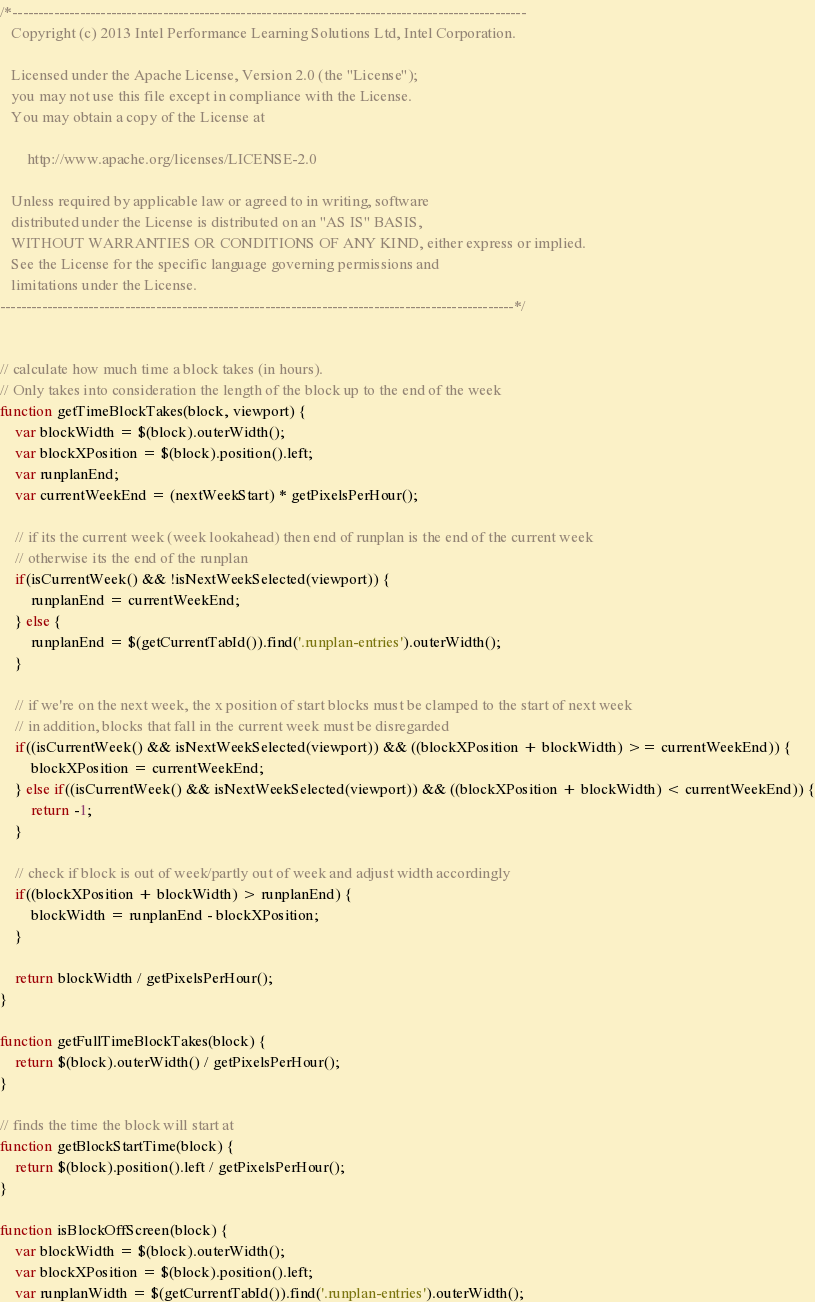<code> <loc_0><loc_0><loc_500><loc_500><_JavaScript_>/*---------------------------------------------------------------------------------------------------
   Copyright (c) 2013 Intel Performance Learning Solutions Ltd, Intel Corporation.

   Licensed under the Apache License, Version 2.0 (the "License");
   you may not use this file except in compliance with the License.
   You may obtain a copy of the License at

       http://www.apache.org/licenses/LICENSE-2.0

   Unless required by applicable law or agreed to in writing, software
   distributed under the License is distributed on an "AS IS" BASIS,
   WITHOUT WARRANTIES OR CONDITIONS OF ANY KIND, either express or implied.
   See the License for the specific language governing permissions and
   limitations under the License.
---------------------------------------------------------------------------------------------------*/


// calculate how much time a block takes (in hours). 
// Only takes into consideration the length of the block up to the end of the week
function getTimeBlockTakes(block, viewport) {
	var blockWidth = $(block).outerWidth();
	var blockXPosition = $(block).position().left;
	var runplanEnd;
	var currentWeekEnd = (nextWeekStart) * getPixelsPerHour();
	
	// if its the current week (week lookahead) then end of runplan is the end of the current week
	// otherwise its the end of the runplan
	if(isCurrentWeek() && !isNextWeekSelected(viewport)) {
		runplanEnd = currentWeekEnd;
	} else {
		runplanEnd = $(getCurrentTabId()).find('.runplan-entries').outerWidth();
	}
	
	// if we're on the next week, the x position of start blocks must be clamped to the start of next week
	// in addition, blocks that fall in the current week must be disregarded
	if((isCurrentWeek() && isNextWeekSelected(viewport)) && ((blockXPosition + blockWidth) >= currentWeekEnd)) {
		blockXPosition = currentWeekEnd;
	} else if((isCurrentWeek() && isNextWeekSelected(viewport)) && ((blockXPosition + blockWidth) < currentWeekEnd)) {
		return -1;
	}
	
	// check if block is out of week/partly out of week and adjust width accordingly
	if((blockXPosition + blockWidth) > runplanEnd) {
		blockWidth = runplanEnd - blockXPosition;
	}
	
	return blockWidth / getPixelsPerHour();
}

function getFullTimeBlockTakes(block) {
	return $(block).outerWidth() / getPixelsPerHour();
}

// finds the time the block will start at
function getBlockStartTime(block) {
	return $(block).position().left / getPixelsPerHour();
}

function isBlockOffScreen(block) {
	var blockWidth = $(block).outerWidth();
	var blockXPosition = $(block).position().left;
	var runplanWidth = $(getCurrentTabId()).find('.runplan-entries').outerWidth();	</code> 